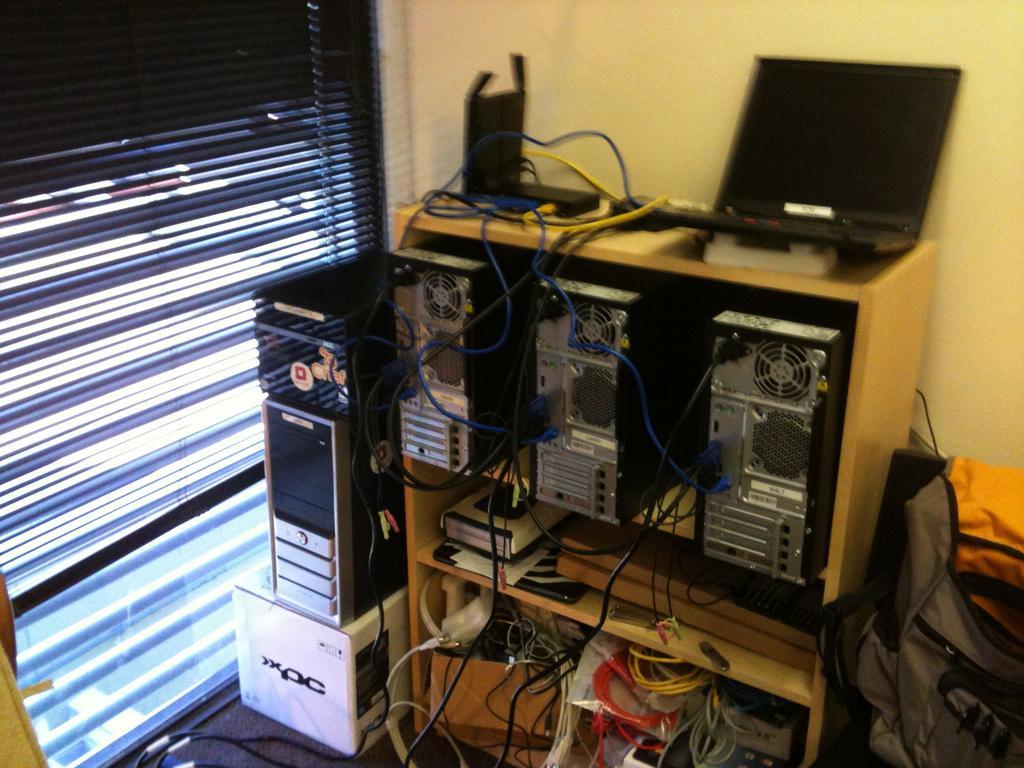Could you give a brief overview of what you see in this image? In this image there is a stand and we can see some equipment placed in the stand. There is a laptop placed on the stand and we can see wires. On the right there is a bag. In the background there is a wall and we can see blinds. 